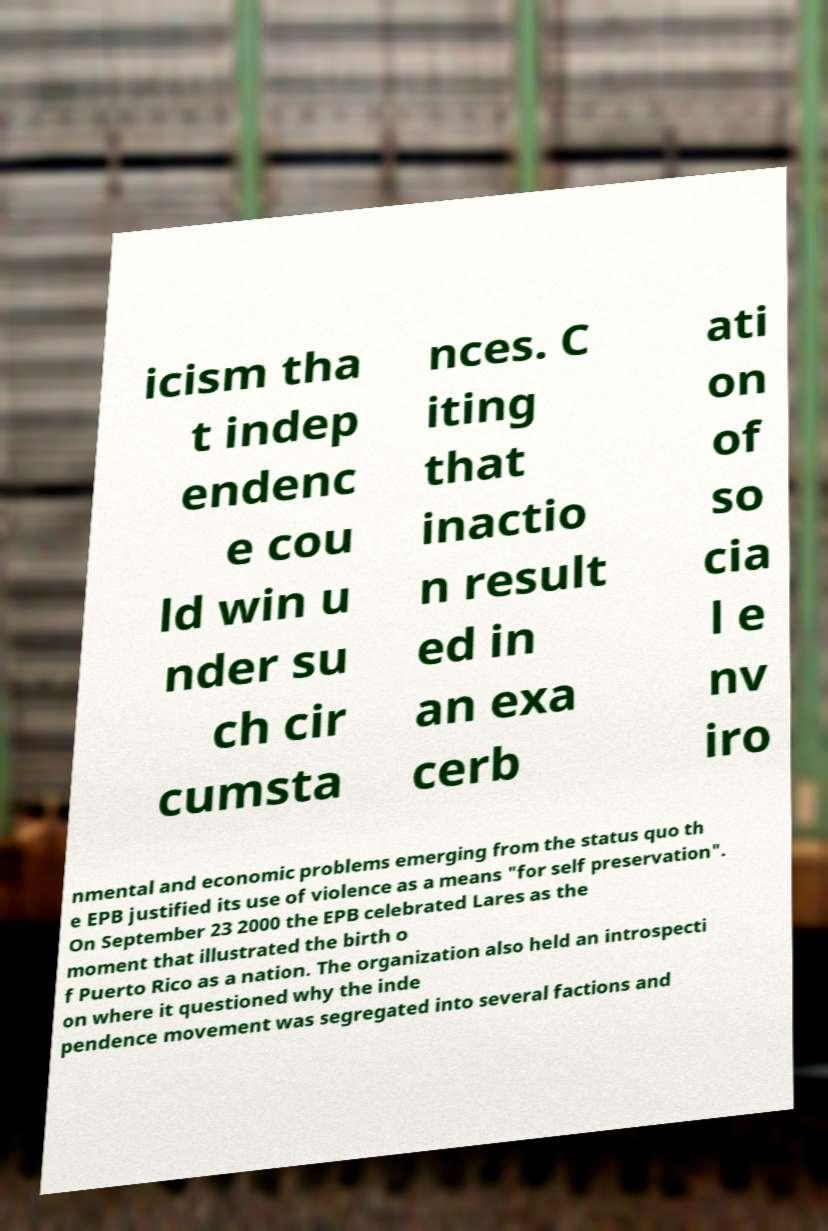Please read and relay the text visible in this image. What does it say? icism tha t indep endenc e cou ld win u nder su ch cir cumsta nces. C iting that inactio n result ed in an exa cerb ati on of so cia l e nv iro nmental and economic problems emerging from the status quo th e EPB justified its use of violence as a means "for self preservation". On September 23 2000 the EPB celebrated Lares as the moment that illustrated the birth o f Puerto Rico as a nation. The organization also held an introspecti on where it questioned why the inde pendence movement was segregated into several factions and 